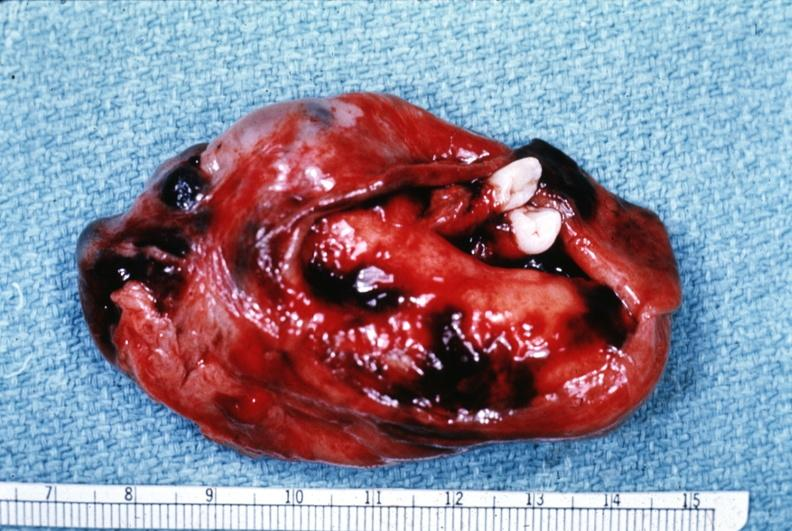s benign cystic teratoma present?
Answer the question using a single word or phrase. Yes 